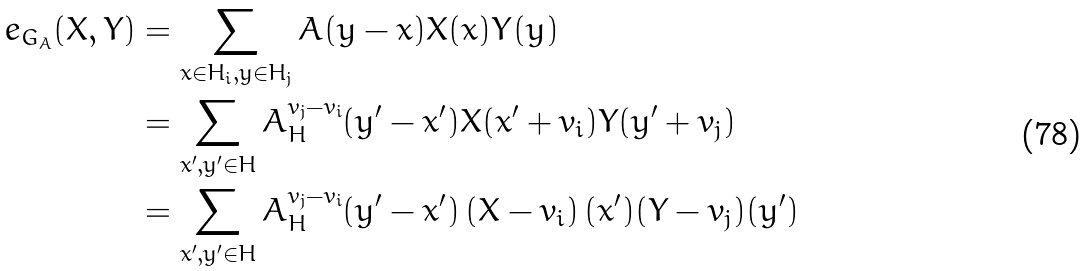Convert formula to latex. <formula><loc_0><loc_0><loc_500><loc_500>e _ { G _ { A } } ( X , Y ) & = \sum _ { x \in H _ { i } , y \in H _ { j } } A ( y - x ) X ( x ) Y ( y ) \\ & = \sum _ { x ^ { \prime } , y ^ { \prime } \in H } A _ { H } ^ { v _ { j } - v _ { i } } ( y ^ { \prime } - x ^ { \prime } ) X ( x ^ { \prime } + v _ { i } ) Y ( y ^ { \prime } + v _ { j } ) \\ & = \sum _ { x ^ { \prime } , y ^ { \prime } \in H } A _ { H } ^ { v _ { j } - v _ { i } } ( y ^ { \prime } - x ^ { \prime } ) \left ( X - v _ { i } \right ) ( x ^ { \prime } ) ( Y - v _ { j } ) ( y ^ { \prime } )</formula> 